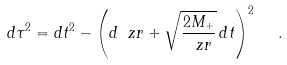Convert formula to latex. <formula><loc_0><loc_0><loc_500><loc_500>d \tau ^ { 2 } = d t ^ { 2 } - \left ( d \ z r + { \sqrt { \frac { 2 M _ { + } } { \ z r } } } \, d t \right ) ^ { 2 } \ \ .</formula> 